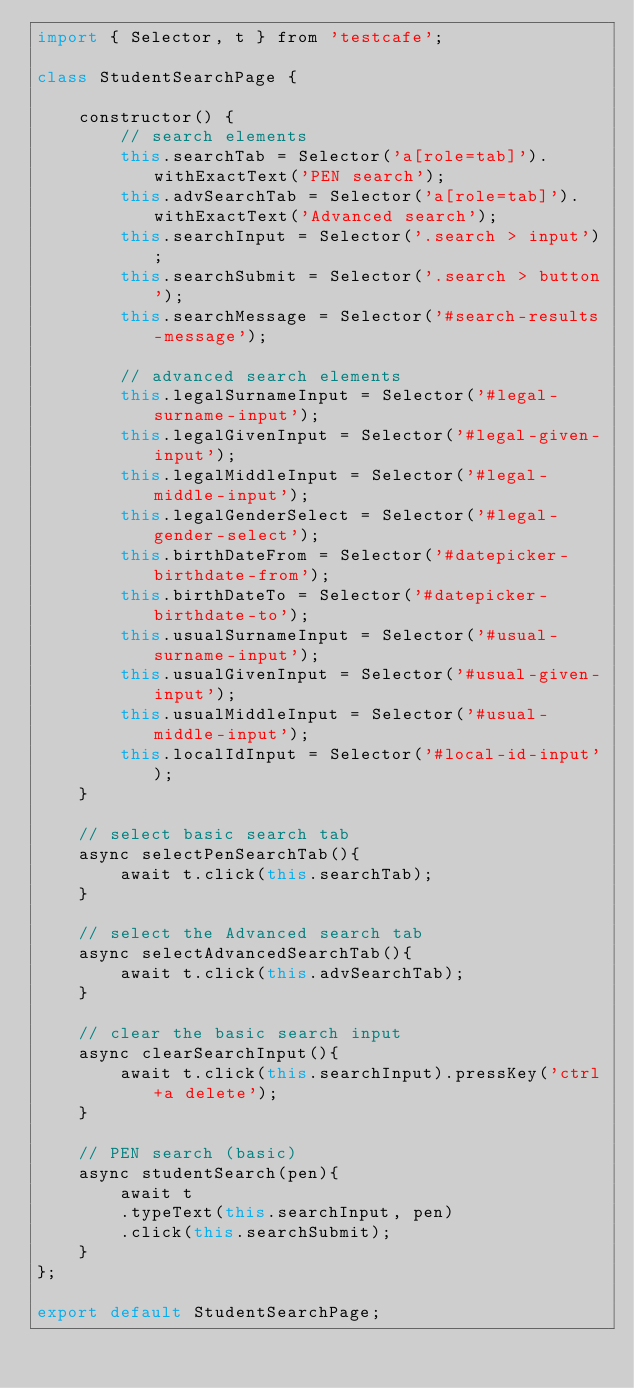<code> <loc_0><loc_0><loc_500><loc_500><_JavaScript_>import { Selector, t } from 'testcafe';

class StudentSearchPage {

    constructor() {
        // search elements
        this.searchTab = Selector('a[role=tab]').withExactText('PEN search');
        this.advSearchTab = Selector('a[role=tab]').withExactText('Advanced search');
        this.searchInput = Selector('.search > input');
        this.searchSubmit = Selector('.search > button');
        this.searchMessage = Selector('#search-results-message');
        
        // advanced search elements
        this.legalSurnameInput = Selector('#legal-surname-input');
        this.legalGivenInput = Selector('#legal-given-input');
        this.legalMiddleInput = Selector('#legal-middle-input');
        this.legalGenderSelect = Selector('#legal-gender-select');
        this.birthDateFrom = Selector('#datepicker-birthdate-from');
        this.birthDateTo = Selector('#datepicker-birthdate-to');
        this.usualSurnameInput = Selector('#usual-surname-input');
        this.usualGivenInput = Selector('#usual-given-input');
        this.usualMiddleInput = Selector('#usual-middle-input');
        this.localIdInput = Selector('#local-id-input');
    }

    // select basic search tab
    async selectPenSearchTab(){
        await t.click(this.searchTab);
    }

    // select the Advanced search tab
    async selectAdvancedSearchTab(){
        await t.click(this.advSearchTab);
    }

    // clear the basic search input
    async clearSearchInput(){
        await t.click(this.searchInput).pressKey('ctrl+a delete');
    }

    // PEN search (basic)
    async studentSearch(pen){
        await t
        .typeText(this.searchInput, pen)
        .click(this.searchSubmit);
    }
};

export default StudentSearchPage;</code> 